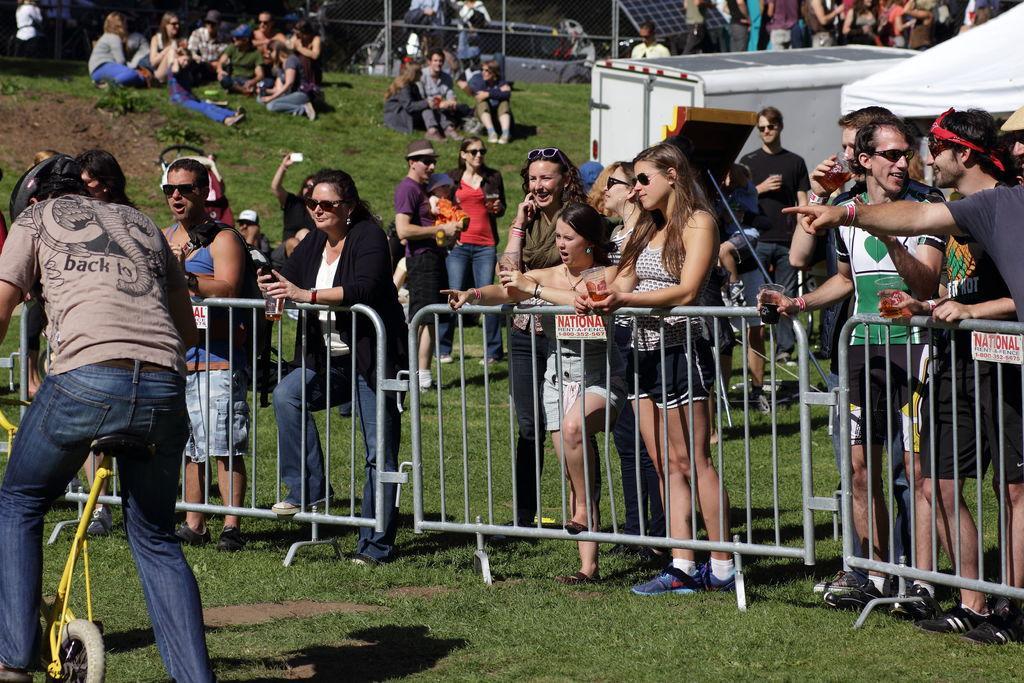Can you describe this image briefly? A man is riding a small bicycle. There are some people beside watching him. 